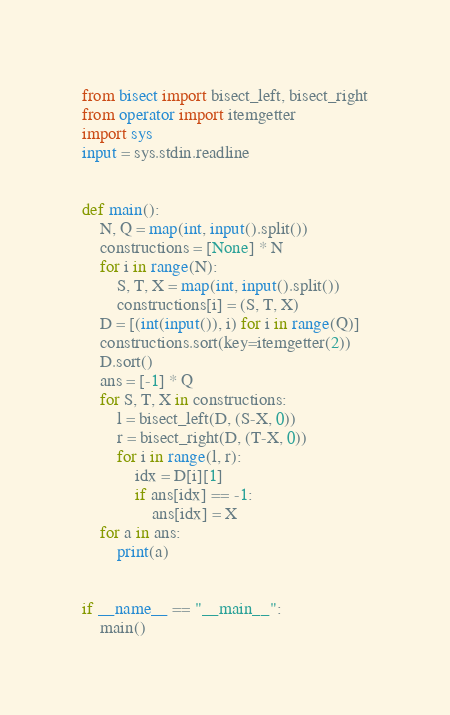<code> <loc_0><loc_0><loc_500><loc_500><_Python_>from bisect import bisect_left, bisect_right
from operator import itemgetter
import sys
input = sys.stdin.readline


def main():
    N, Q = map(int, input().split())
    constructions = [None] * N
    for i in range(N):
        S, T, X = map(int, input().split())
        constructions[i] = (S, T, X)
    D = [(int(input()), i) for i in range(Q)]
    constructions.sort(key=itemgetter(2))
    D.sort()
    ans = [-1] * Q
    for S, T, X in constructions:
        l = bisect_left(D, (S-X, 0))
        r = bisect_right(D, (T-X, 0))
        for i in range(l, r):
            idx = D[i][1]
            if ans[idx] == -1:
                ans[idx] = X
    for a in ans:
        print(a)


if __name__ == "__main__":
    main()
</code> 